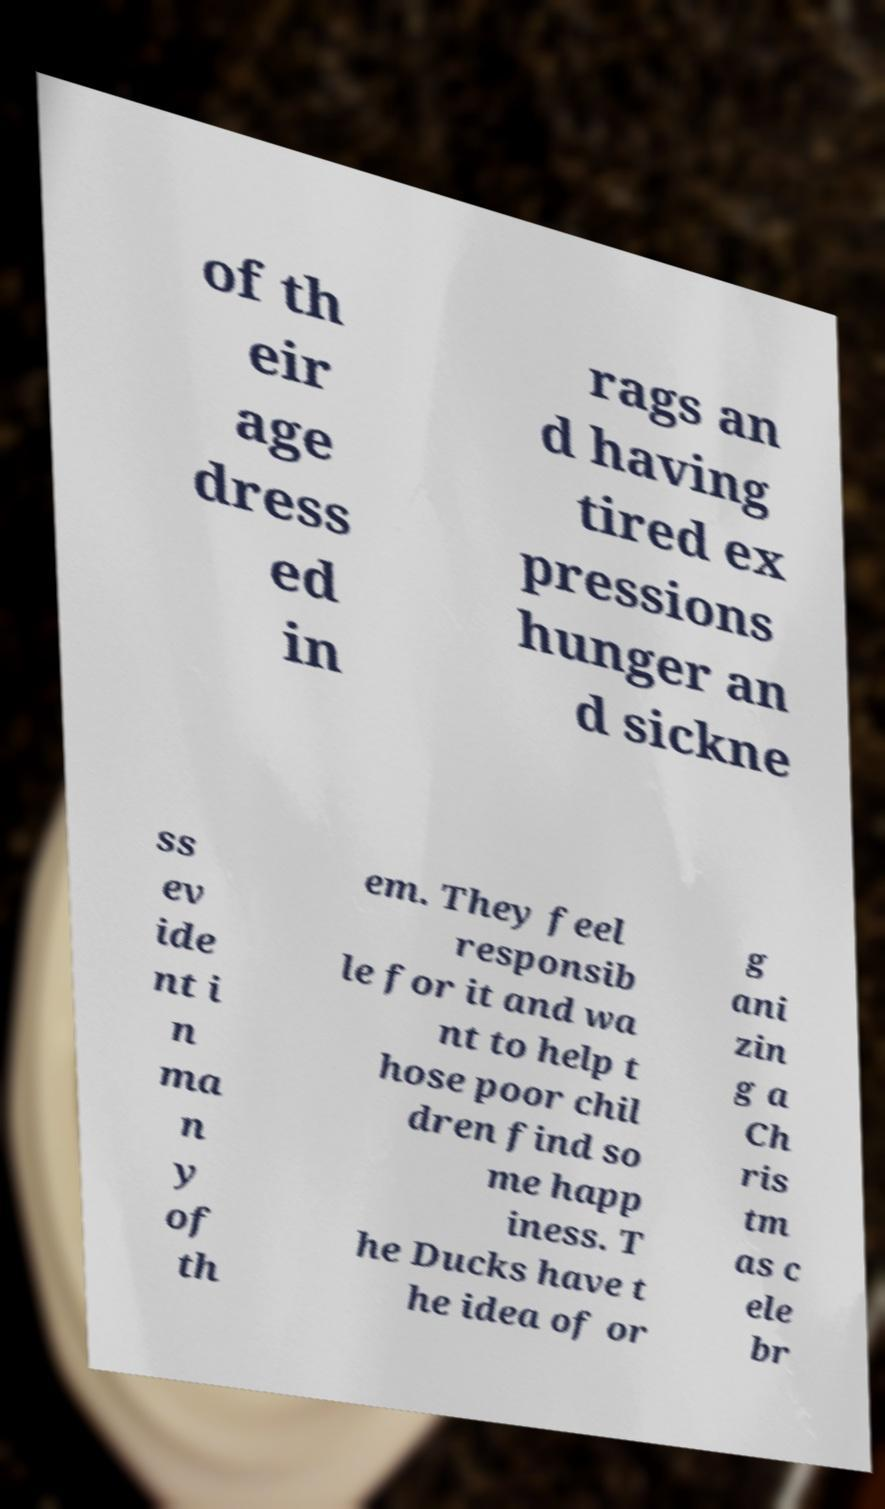Please read and relay the text visible in this image. What does it say? of th eir age dress ed in rags an d having tired ex pressions hunger an d sickne ss ev ide nt i n ma n y of th em. They feel responsib le for it and wa nt to help t hose poor chil dren find so me happ iness. T he Ducks have t he idea of or g ani zin g a Ch ris tm as c ele br 